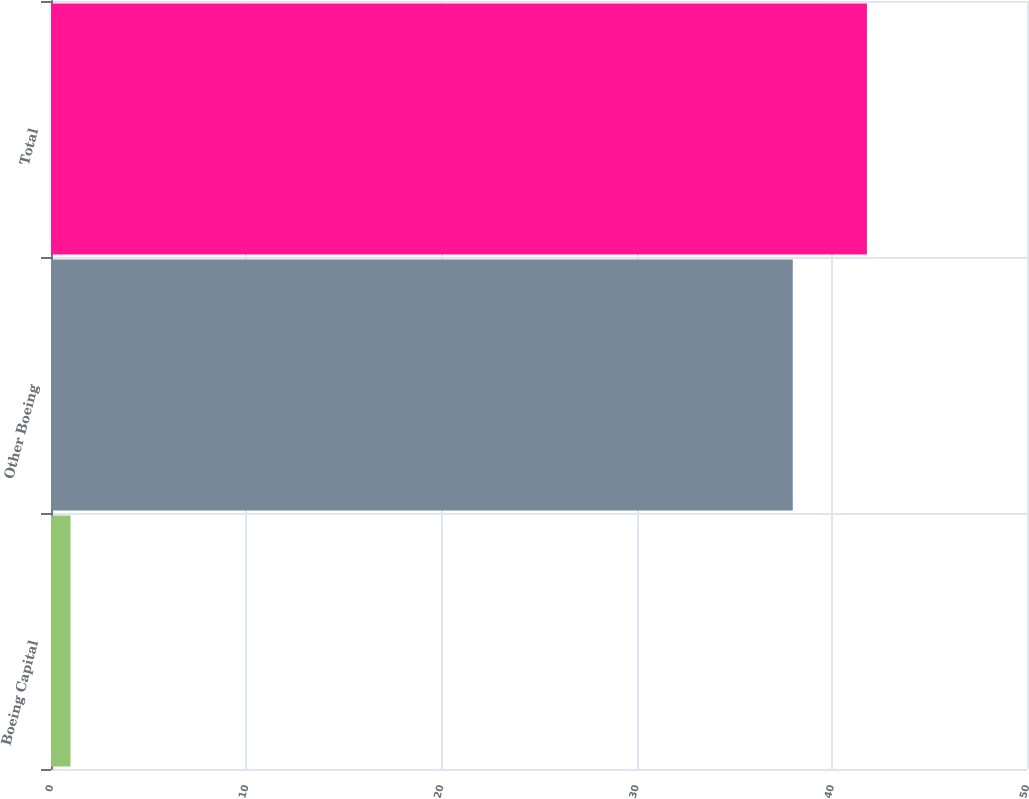Convert chart to OTSL. <chart><loc_0><loc_0><loc_500><loc_500><bar_chart><fcel>Boeing Capital<fcel>Other Boeing<fcel>Total<nl><fcel>1<fcel>38<fcel>41.8<nl></chart> 